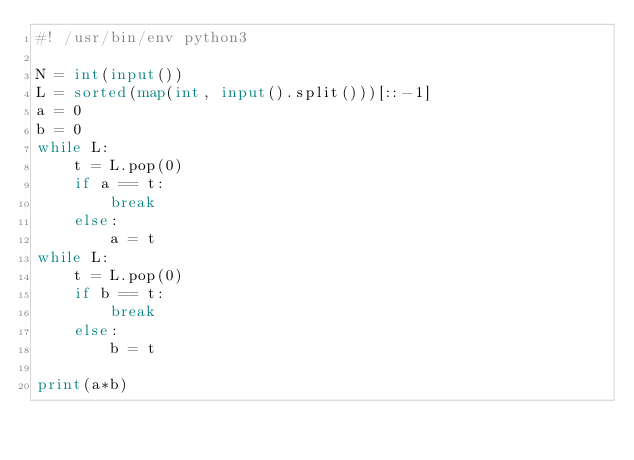Convert code to text. <code><loc_0><loc_0><loc_500><loc_500><_Python_>#! /usr/bin/env python3

N = int(input())
L = sorted(map(int, input().split()))[::-1]
a = 0
b = 0
while L:
    t = L.pop(0)
    if a == t:
        break
    else:
        a = t
while L:
    t = L.pop(0)
    if b == t:
        break
    else:
        b = t
    
print(a*b)</code> 